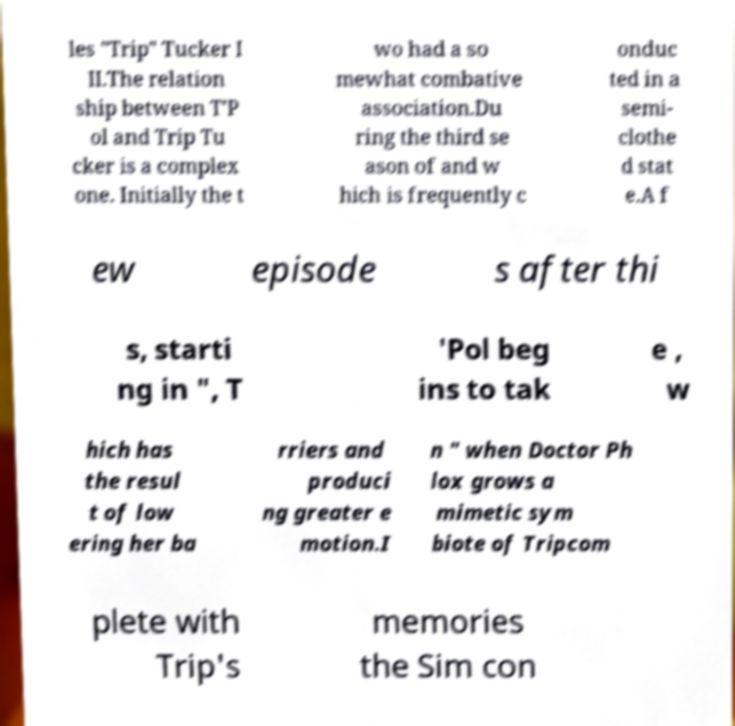I need the written content from this picture converted into text. Can you do that? les "Trip" Tucker I II.The relation ship between T'P ol and Trip Tu cker is a complex one. Initially the t wo had a so mewhat combative association.Du ring the third se ason of and w hich is frequently c onduc ted in a semi- clothe d stat e.A f ew episode s after thi s, starti ng in ", T 'Pol beg ins to tak e , w hich has the resul t of low ering her ba rriers and produci ng greater e motion.I n " when Doctor Ph lox grows a mimetic sym biote of Tripcom plete with Trip's memories the Sim con 